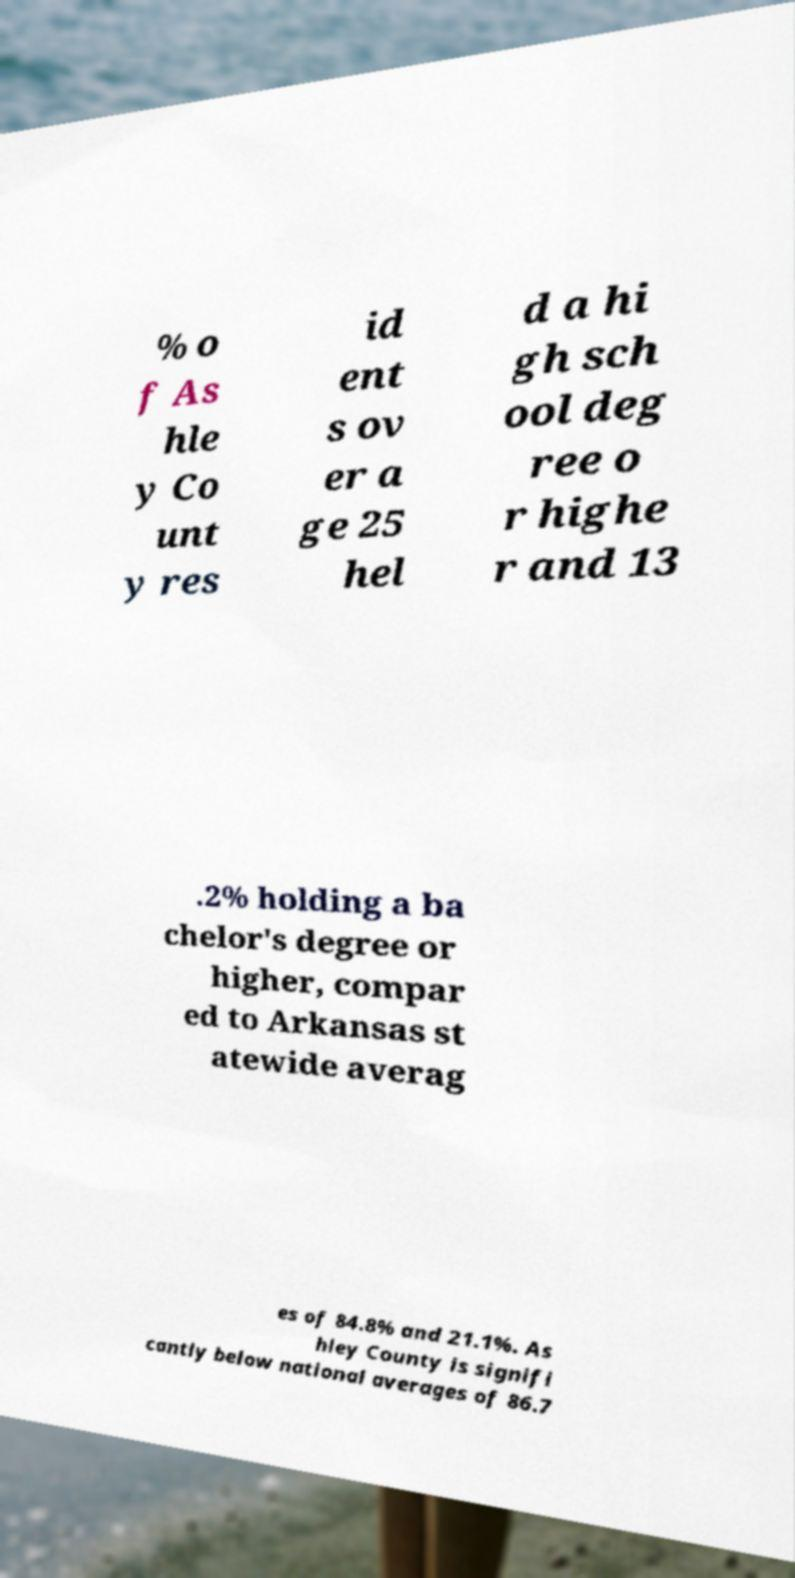What messages or text are displayed in this image? I need them in a readable, typed format. % o f As hle y Co unt y res id ent s ov er a ge 25 hel d a hi gh sch ool deg ree o r highe r and 13 .2% holding a ba chelor's degree or higher, compar ed to Arkansas st atewide averag es of 84.8% and 21.1%. As hley County is signifi cantly below national averages of 86.7 